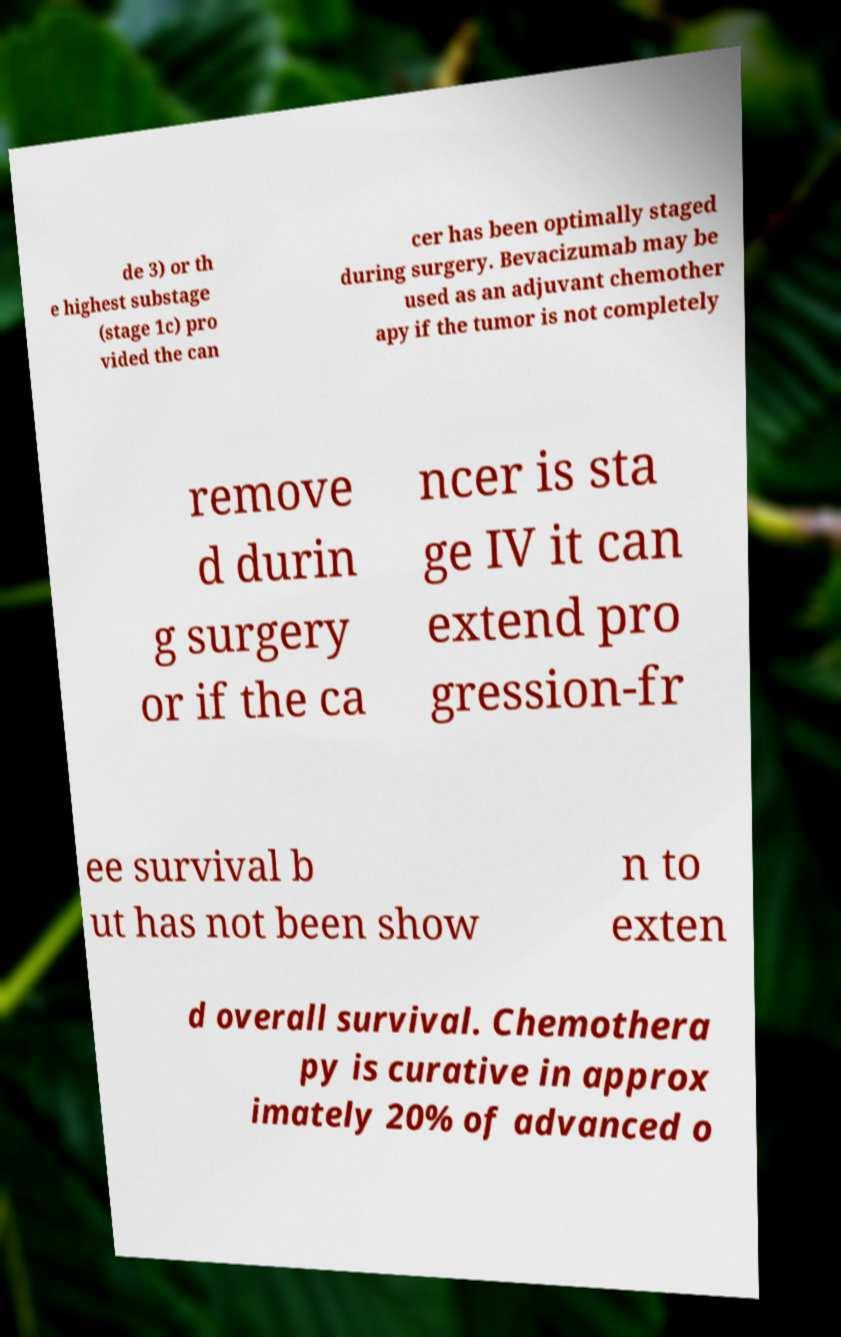For documentation purposes, I need the text within this image transcribed. Could you provide that? de 3) or th e highest substage (stage 1c) pro vided the can cer has been optimally staged during surgery. Bevacizumab may be used as an adjuvant chemother apy if the tumor is not completely remove d durin g surgery or if the ca ncer is sta ge IV it can extend pro gression-fr ee survival b ut has not been show n to exten d overall survival. Chemothera py is curative in approx imately 20% of advanced o 